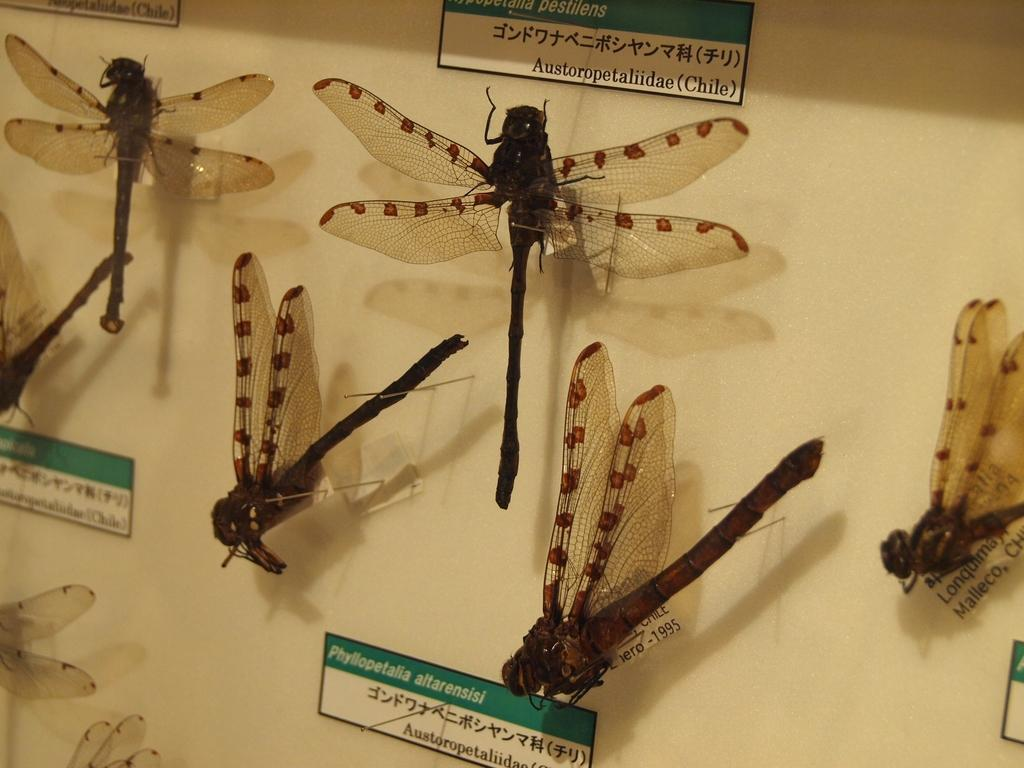What type of insects can be seen in the image? There are flies in the image. What is the background of the image? There is a wall in the image. What objects are used to attach or hold something in the image? There are pins in the image. What type of signage is present in the image? There are information boards in the image. What type of boot is hanging on the wall in the image? There is no boot present in the image; it only features flies, a wall, pins, and information boards. 